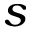Convert formula to latex. <formula><loc_0><loc_0><loc_500><loc_500>s</formula> 